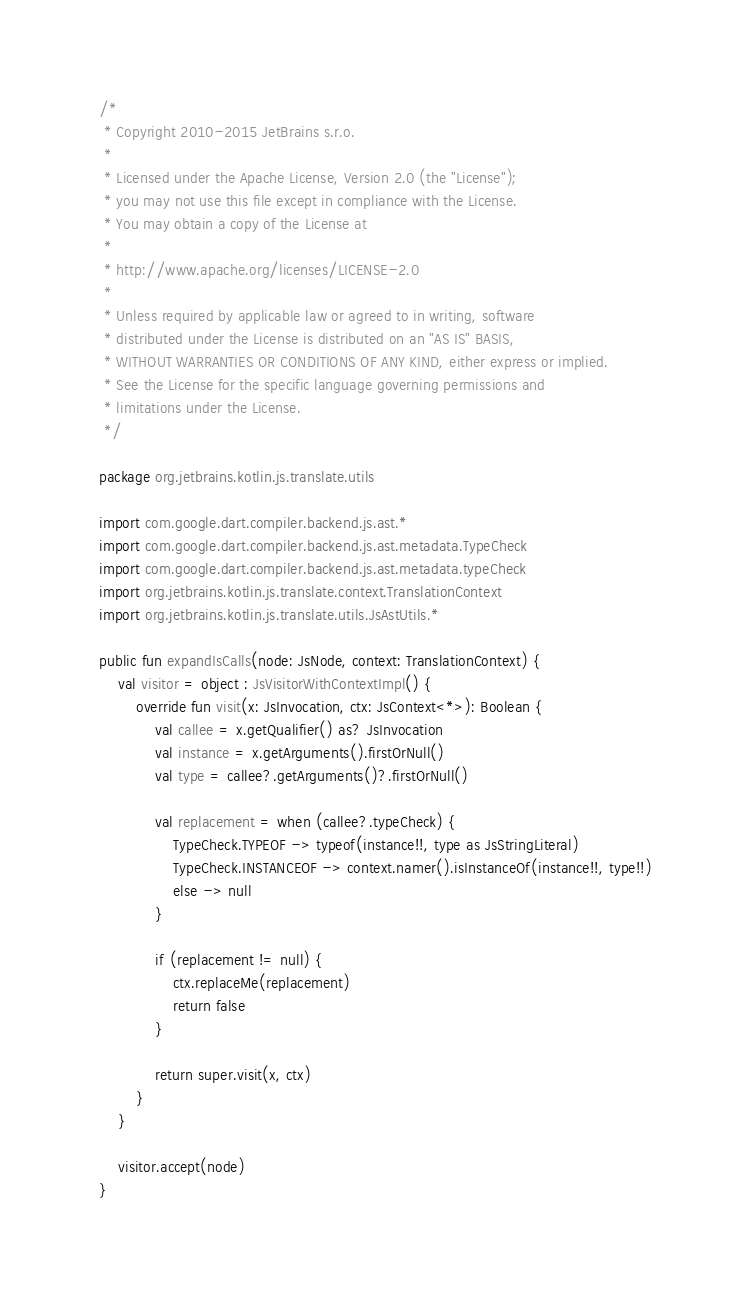Convert code to text. <code><loc_0><loc_0><loc_500><loc_500><_Kotlin_>/*
 * Copyright 2010-2015 JetBrains s.r.o.
 *
 * Licensed under the Apache License, Version 2.0 (the "License");
 * you may not use this file except in compliance with the License.
 * You may obtain a copy of the License at
 *
 * http://www.apache.org/licenses/LICENSE-2.0
 *
 * Unless required by applicable law or agreed to in writing, software
 * distributed under the License is distributed on an "AS IS" BASIS,
 * WITHOUT WARRANTIES OR CONDITIONS OF ANY KIND, either express or implied.
 * See the License for the specific language governing permissions and
 * limitations under the License.
 */

package org.jetbrains.kotlin.js.translate.utils

import com.google.dart.compiler.backend.js.ast.*
import com.google.dart.compiler.backend.js.ast.metadata.TypeCheck
import com.google.dart.compiler.backend.js.ast.metadata.typeCheck
import org.jetbrains.kotlin.js.translate.context.TranslationContext
import org.jetbrains.kotlin.js.translate.utils.JsAstUtils.*

public fun expandIsCalls(node: JsNode, context: TranslationContext) {
    val visitor = object : JsVisitorWithContextImpl() {
        override fun visit(x: JsInvocation, ctx: JsContext<*>): Boolean {
            val callee = x.getQualifier() as? JsInvocation
            val instance = x.getArguments().firstOrNull()
            val type = callee?.getArguments()?.firstOrNull()

            val replacement = when (callee?.typeCheck) {
                TypeCheck.TYPEOF -> typeof(instance!!, type as JsStringLiteral)
                TypeCheck.INSTANCEOF -> context.namer().isInstanceOf(instance!!, type!!)
                else -> null
            }

            if (replacement != null) {
                ctx.replaceMe(replacement)
                return false
            }

            return super.visit(x, ctx)
        }
    }

    visitor.accept(node)
}
</code> 